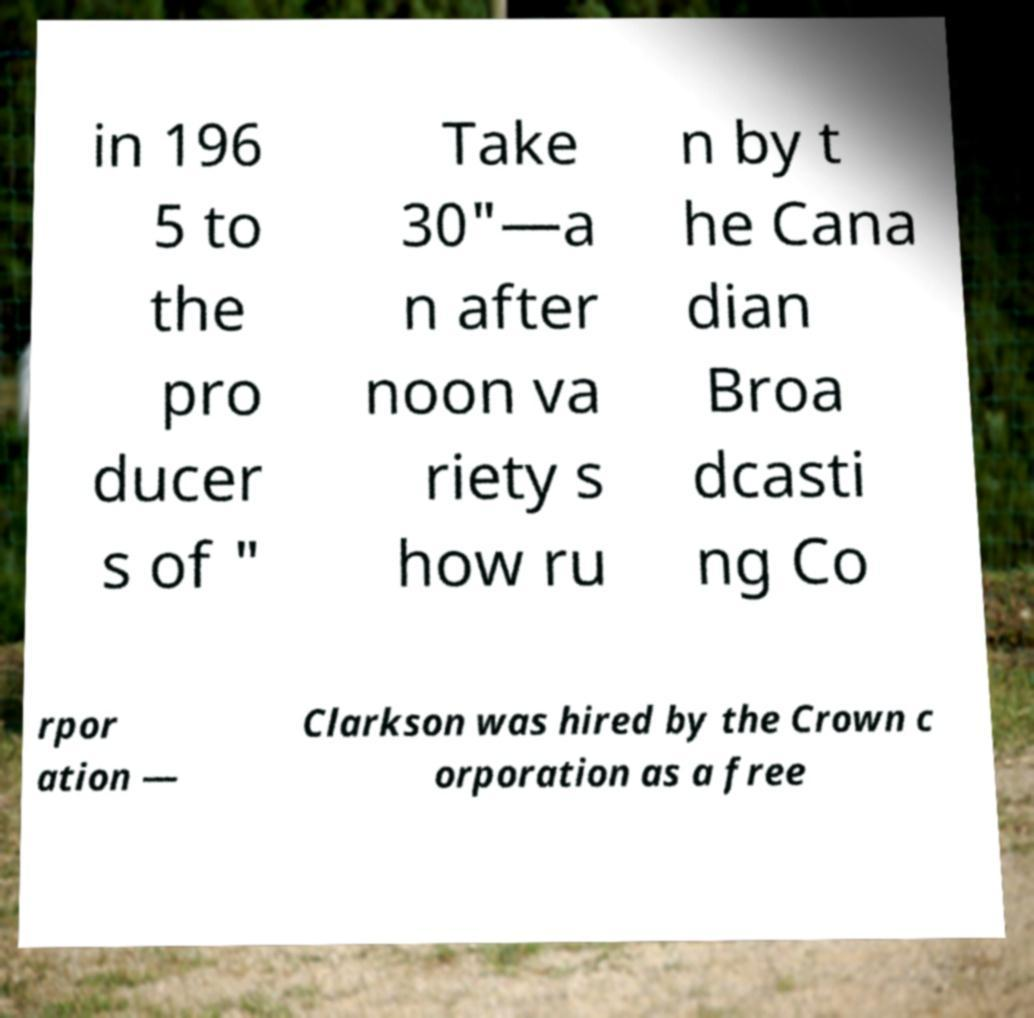Could you extract and type out the text from this image? in 196 5 to the pro ducer s of " Take 30"—a n after noon va riety s how ru n by t he Cana dian Broa dcasti ng Co rpor ation — Clarkson was hired by the Crown c orporation as a free 